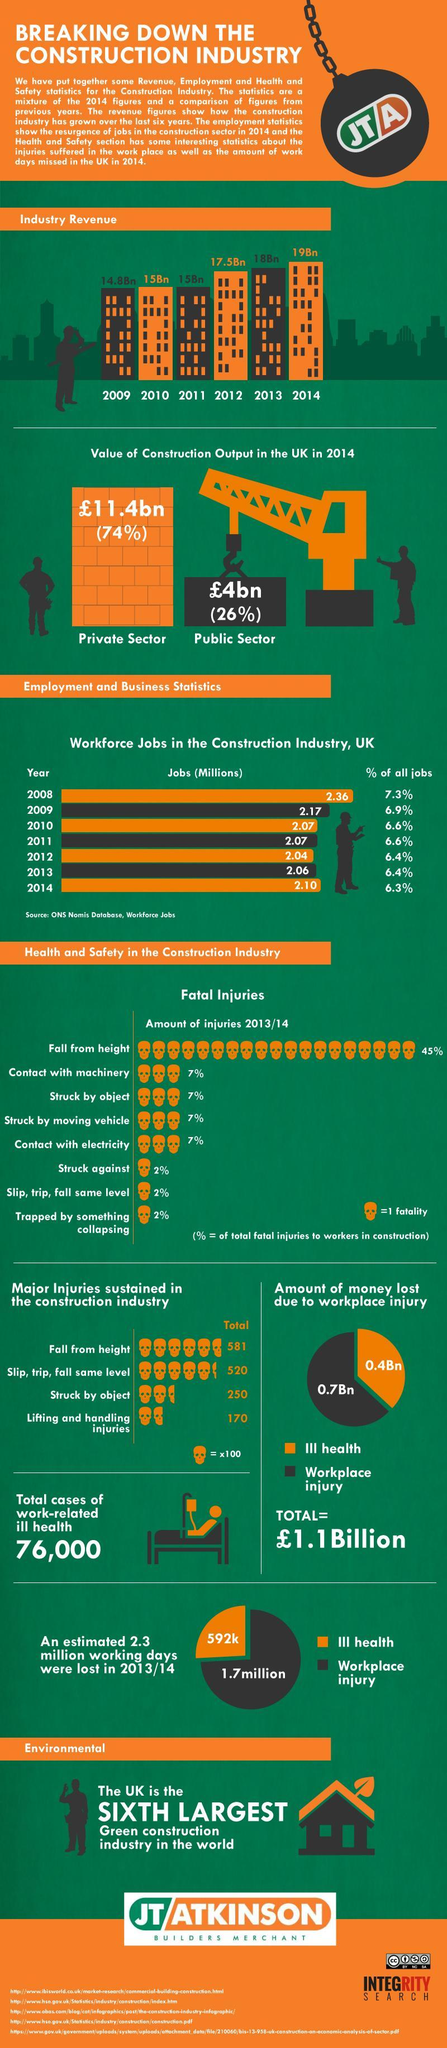What percent of fatal injuries is caused by contact with machinery and contact with electricity?
Answer the question with a short phrase. 14% Which sector contributes to the most value of construction output in UK? Private Sector How many major injuries are sustained in the construction industry due to struck by object and fall from height? 831 Which three reasons each corresponding to 2% cause fatal injuries? Struck against, Slip,trip,fall same level, Trapped by something collapsing In 2013, what was the percentage of all jobs? 6.4% Which causes more loss of money - Ill health or workplace injury? Workplace injury What is the increase in industry revenue from 2009 to 2014? 4.2Bn How many sources are listed at the bottom? 5 Which two years had 2.07 Million jobs each in the construction industry? 2010, 2011 